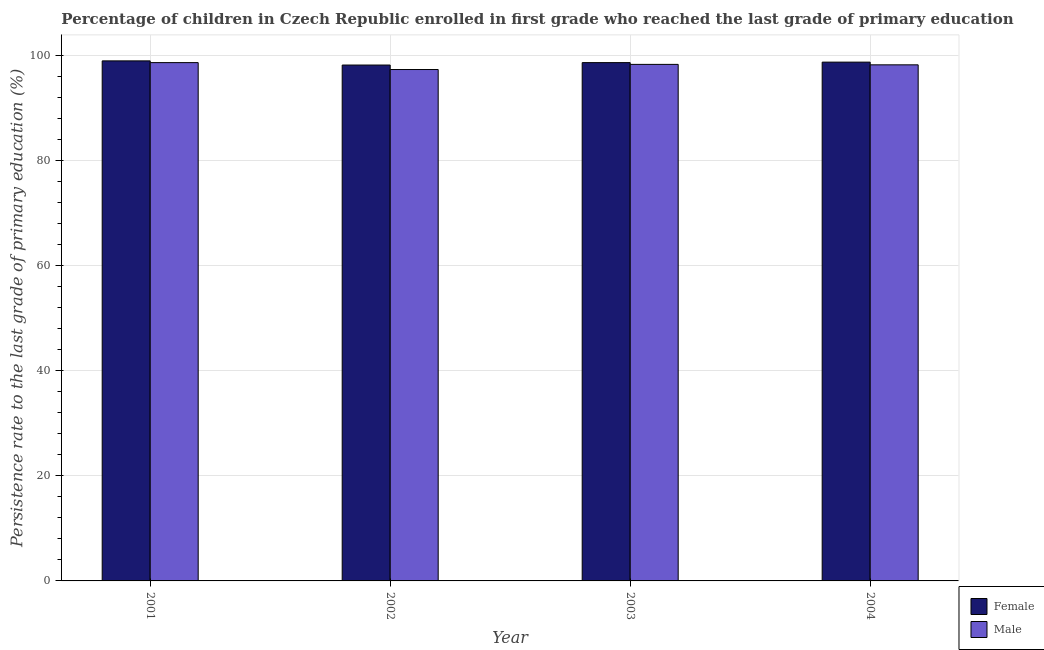How many groups of bars are there?
Make the answer very short. 4. Are the number of bars on each tick of the X-axis equal?
Keep it short and to the point. Yes. How many bars are there on the 2nd tick from the left?
Provide a short and direct response. 2. How many bars are there on the 4th tick from the right?
Provide a succinct answer. 2. What is the label of the 4th group of bars from the left?
Your answer should be very brief. 2004. In how many cases, is the number of bars for a given year not equal to the number of legend labels?
Offer a terse response. 0. What is the persistence rate of female students in 2001?
Offer a terse response. 98.92. Across all years, what is the maximum persistence rate of female students?
Provide a short and direct response. 98.92. Across all years, what is the minimum persistence rate of male students?
Provide a short and direct response. 97.27. In which year was the persistence rate of female students maximum?
Make the answer very short. 2001. What is the total persistence rate of male students in the graph?
Offer a very short reply. 392.28. What is the difference between the persistence rate of male students in 2003 and that in 2004?
Your answer should be very brief. 0.09. What is the difference between the persistence rate of female students in 2004 and the persistence rate of male students in 2002?
Keep it short and to the point. 0.56. What is the average persistence rate of male students per year?
Offer a terse response. 98.07. In the year 2004, what is the difference between the persistence rate of male students and persistence rate of female students?
Provide a short and direct response. 0. What is the ratio of the persistence rate of male students in 2001 to that in 2002?
Your response must be concise. 1.01. What is the difference between the highest and the second highest persistence rate of female students?
Offer a very short reply. 0.24. What is the difference between the highest and the lowest persistence rate of female students?
Offer a very short reply. 0.79. In how many years, is the persistence rate of female students greater than the average persistence rate of female students taken over all years?
Make the answer very short. 3. What does the 1st bar from the left in 2003 represents?
Your answer should be very brief. Female. Are all the bars in the graph horizontal?
Provide a short and direct response. No. How many years are there in the graph?
Offer a very short reply. 4. What is the difference between two consecutive major ticks on the Y-axis?
Keep it short and to the point. 20. Does the graph contain grids?
Offer a very short reply. Yes. What is the title of the graph?
Provide a short and direct response. Percentage of children in Czech Republic enrolled in first grade who reached the last grade of primary education. What is the label or title of the X-axis?
Your answer should be very brief. Year. What is the label or title of the Y-axis?
Make the answer very short. Persistence rate to the last grade of primary education (%). What is the Persistence rate to the last grade of primary education (%) in Female in 2001?
Your response must be concise. 98.92. What is the Persistence rate to the last grade of primary education (%) of Male in 2001?
Provide a succinct answer. 98.59. What is the Persistence rate to the last grade of primary education (%) in Female in 2002?
Your answer should be very brief. 98.13. What is the Persistence rate to the last grade of primary education (%) of Male in 2002?
Offer a very short reply. 97.27. What is the Persistence rate to the last grade of primary education (%) of Female in 2003?
Ensure brevity in your answer.  98.59. What is the Persistence rate to the last grade of primary education (%) in Male in 2003?
Give a very brief answer. 98.25. What is the Persistence rate to the last grade of primary education (%) in Female in 2004?
Your answer should be compact. 98.68. What is the Persistence rate to the last grade of primary education (%) in Male in 2004?
Your response must be concise. 98.17. Across all years, what is the maximum Persistence rate to the last grade of primary education (%) of Female?
Provide a succinct answer. 98.92. Across all years, what is the maximum Persistence rate to the last grade of primary education (%) of Male?
Ensure brevity in your answer.  98.59. Across all years, what is the minimum Persistence rate to the last grade of primary education (%) in Female?
Your answer should be very brief. 98.13. Across all years, what is the minimum Persistence rate to the last grade of primary education (%) of Male?
Ensure brevity in your answer.  97.27. What is the total Persistence rate to the last grade of primary education (%) in Female in the graph?
Your answer should be very brief. 394.31. What is the total Persistence rate to the last grade of primary education (%) in Male in the graph?
Offer a terse response. 392.28. What is the difference between the Persistence rate to the last grade of primary education (%) in Female in 2001 and that in 2002?
Give a very brief answer. 0.79. What is the difference between the Persistence rate to the last grade of primary education (%) of Male in 2001 and that in 2002?
Provide a short and direct response. 1.31. What is the difference between the Persistence rate to the last grade of primary education (%) in Female in 2001 and that in 2003?
Make the answer very short. 0.33. What is the difference between the Persistence rate to the last grade of primary education (%) of Male in 2001 and that in 2003?
Ensure brevity in your answer.  0.34. What is the difference between the Persistence rate to the last grade of primary education (%) of Female in 2001 and that in 2004?
Give a very brief answer. 0.24. What is the difference between the Persistence rate to the last grade of primary education (%) of Male in 2001 and that in 2004?
Offer a terse response. 0.42. What is the difference between the Persistence rate to the last grade of primary education (%) of Female in 2002 and that in 2003?
Ensure brevity in your answer.  -0.46. What is the difference between the Persistence rate to the last grade of primary education (%) of Male in 2002 and that in 2003?
Offer a very short reply. -0.98. What is the difference between the Persistence rate to the last grade of primary education (%) of Female in 2002 and that in 2004?
Make the answer very short. -0.56. What is the difference between the Persistence rate to the last grade of primary education (%) in Male in 2002 and that in 2004?
Your answer should be compact. -0.89. What is the difference between the Persistence rate to the last grade of primary education (%) of Female in 2003 and that in 2004?
Ensure brevity in your answer.  -0.09. What is the difference between the Persistence rate to the last grade of primary education (%) in Male in 2003 and that in 2004?
Keep it short and to the point. 0.09. What is the difference between the Persistence rate to the last grade of primary education (%) of Female in 2001 and the Persistence rate to the last grade of primary education (%) of Male in 2002?
Your answer should be very brief. 1.64. What is the difference between the Persistence rate to the last grade of primary education (%) of Female in 2001 and the Persistence rate to the last grade of primary education (%) of Male in 2003?
Your response must be concise. 0.67. What is the difference between the Persistence rate to the last grade of primary education (%) in Female in 2001 and the Persistence rate to the last grade of primary education (%) in Male in 2004?
Make the answer very short. 0.75. What is the difference between the Persistence rate to the last grade of primary education (%) in Female in 2002 and the Persistence rate to the last grade of primary education (%) in Male in 2003?
Your response must be concise. -0.13. What is the difference between the Persistence rate to the last grade of primary education (%) in Female in 2002 and the Persistence rate to the last grade of primary education (%) in Male in 2004?
Your response must be concise. -0.04. What is the difference between the Persistence rate to the last grade of primary education (%) of Female in 2003 and the Persistence rate to the last grade of primary education (%) of Male in 2004?
Offer a terse response. 0.42. What is the average Persistence rate to the last grade of primary education (%) in Female per year?
Your answer should be compact. 98.58. What is the average Persistence rate to the last grade of primary education (%) in Male per year?
Offer a very short reply. 98.07. In the year 2001, what is the difference between the Persistence rate to the last grade of primary education (%) of Female and Persistence rate to the last grade of primary education (%) of Male?
Your answer should be compact. 0.33. In the year 2002, what is the difference between the Persistence rate to the last grade of primary education (%) of Female and Persistence rate to the last grade of primary education (%) of Male?
Ensure brevity in your answer.  0.85. In the year 2003, what is the difference between the Persistence rate to the last grade of primary education (%) in Female and Persistence rate to the last grade of primary education (%) in Male?
Give a very brief answer. 0.34. In the year 2004, what is the difference between the Persistence rate to the last grade of primary education (%) in Female and Persistence rate to the last grade of primary education (%) in Male?
Offer a very short reply. 0.52. What is the ratio of the Persistence rate to the last grade of primary education (%) of Male in 2001 to that in 2002?
Provide a short and direct response. 1.01. What is the ratio of the Persistence rate to the last grade of primary education (%) of Male in 2001 to that in 2004?
Give a very brief answer. 1. What is the ratio of the Persistence rate to the last grade of primary education (%) of Female in 2002 to that in 2003?
Make the answer very short. 1. What is the ratio of the Persistence rate to the last grade of primary education (%) in Male in 2002 to that in 2004?
Ensure brevity in your answer.  0.99. What is the ratio of the Persistence rate to the last grade of primary education (%) of Female in 2003 to that in 2004?
Keep it short and to the point. 1. What is the ratio of the Persistence rate to the last grade of primary education (%) of Male in 2003 to that in 2004?
Keep it short and to the point. 1. What is the difference between the highest and the second highest Persistence rate to the last grade of primary education (%) in Female?
Keep it short and to the point. 0.24. What is the difference between the highest and the second highest Persistence rate to the last grade of primary education (%) in Male?
Offer a very short reply. 0.34. What is the difference between the highest and the lowest Persistence rate to the last grade of primary education (%) in Female?
Make the answer very short. 0.79. What is the difference between the highest and the lowest Persistence rate to the last grade of primary education (%) of Male?
Offer a terse response. 1.31. 